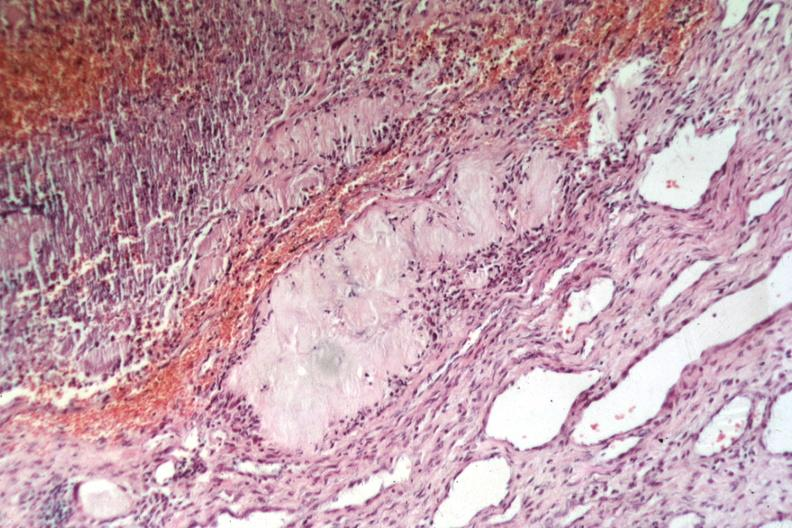does this image show easily recognized uric acid deposit lesion from elbow?
Answer the question using a single word or phrase. Yes 